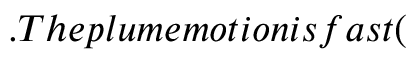<formula> <loc_0><loc_0><loc_500><loc_500>. T h e p l u m e m o t i o n i s f a s t (</formula> 